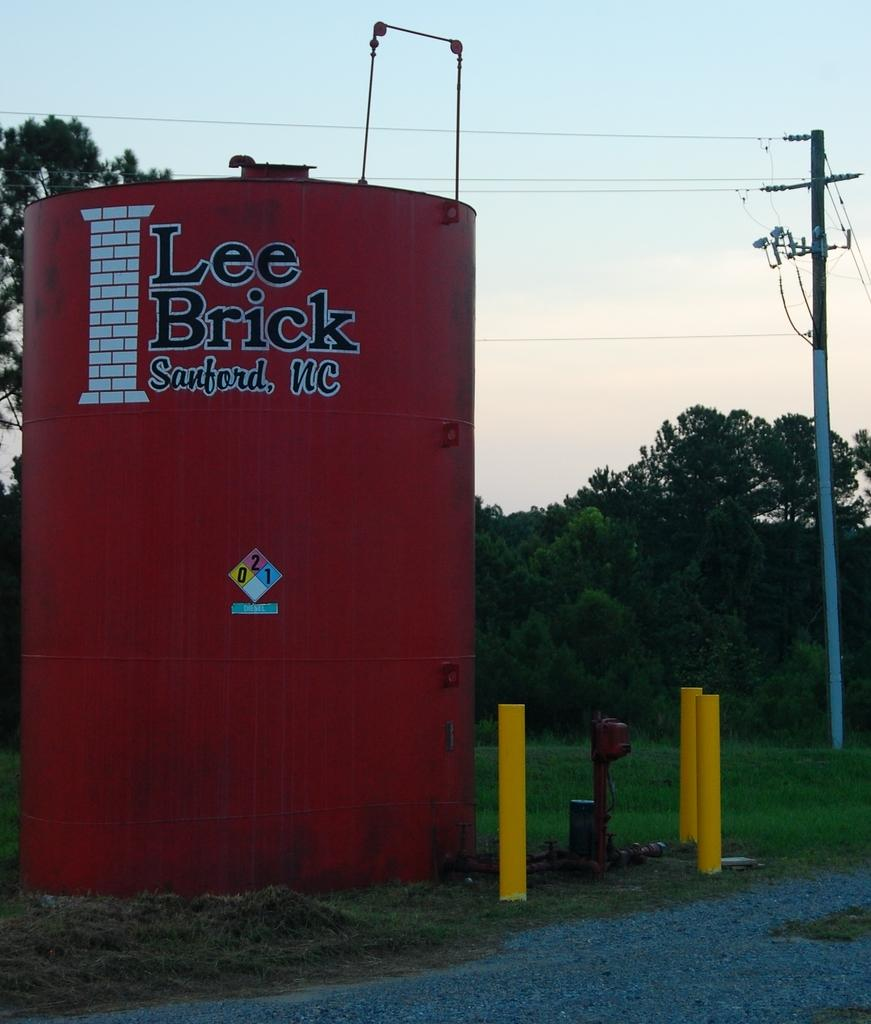What object is present in the image that can hold items? There is a container in the image that can hold items. What type of natural environment is visible in the image? There is grass in the image, which suggests a natural environment. What are the tall, vertical structures in the image? There are poles in the image. What can be found written on the container? Something is written on the container. What is visible in the background of the image? The background of the image includes the sky and trees. How many apples are hanging from the poles in the image? There are no apples present in the image; the poles are not associated with any fruit. Can you see the ear of the person in the image? There is no person present in the image, so it is not possible to see their ear. 